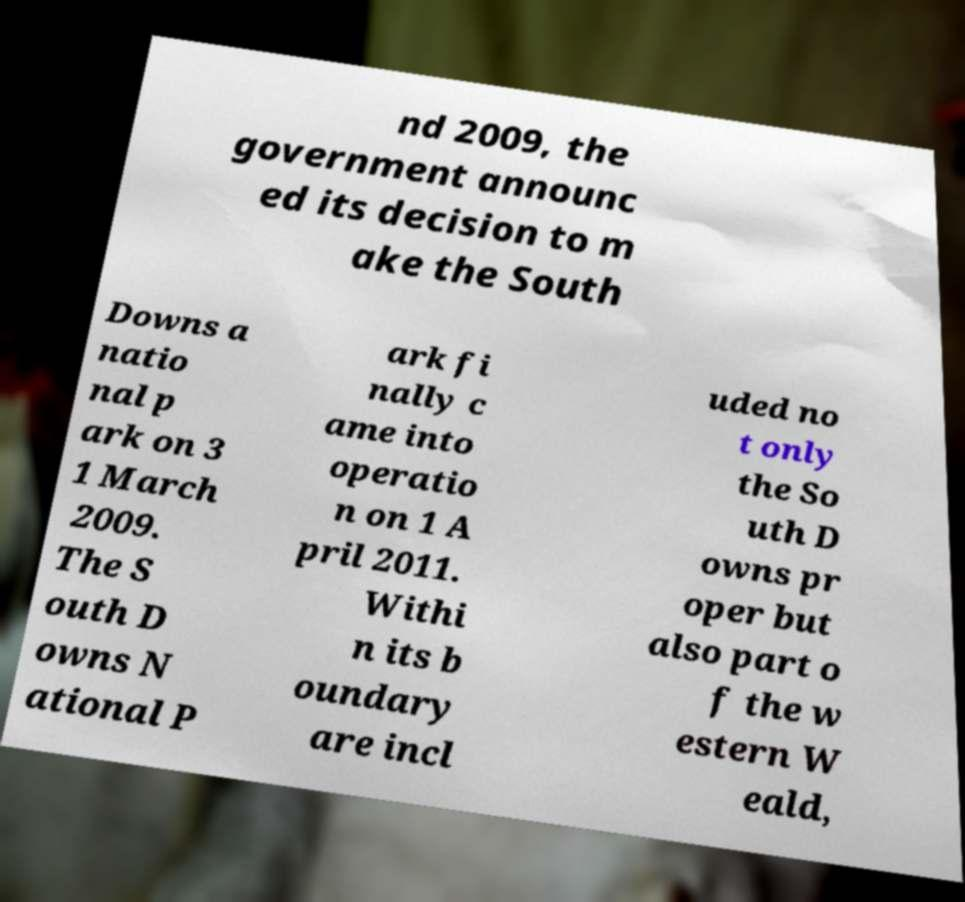There's text embedded in this image that I need extracted. Can you transcribe it verbatim? nd 2009, the government announc ed its decision to m ake the South Downs a natio nal p ark on 3 1 March 2009. The S outh D owns N ational P ark fi nally c ame into operatio n on 1 A pril 2011. Withi n its b oundary are incl uded no t only the So uth D owns pr oper but also part o f the w estern W eald, 